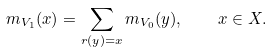Convert formula to latex. <formula><loc_0><loc_0><loc_500><loc_500>m _ { V _ { 1 } } ( x ) = \sum _ { r ( y ) = x } m _ { V _ { 0 } } ( y ) , \quad x \in X .</formula> 